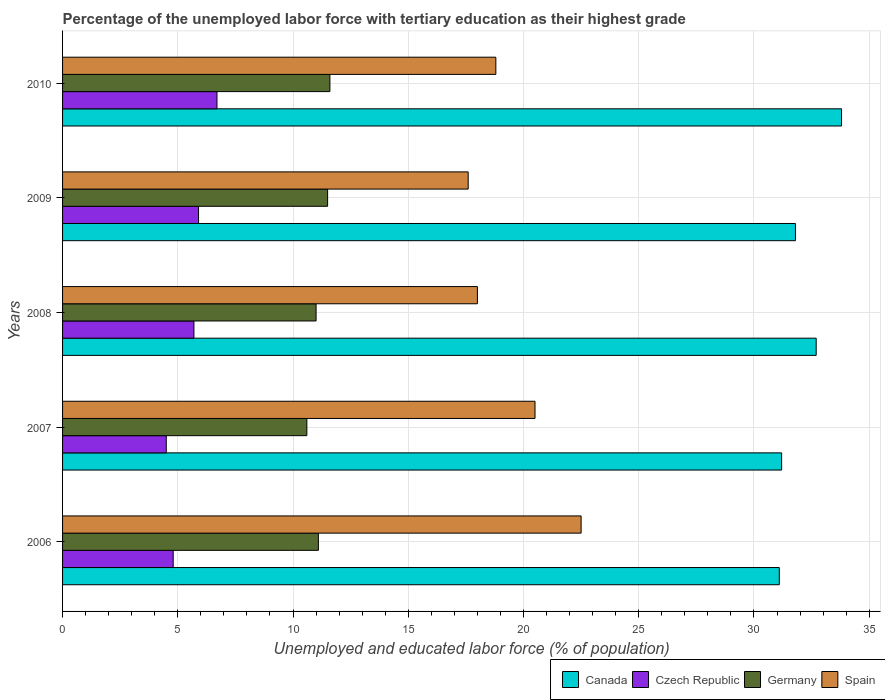How many different coloured bars are there?
Provide a short and direct response. 4. How many bars are there on the 3rd tick from the top?
Your answer should be very brief. 4. In how many cases, is the number of bars for a given year not equal to the number of legend labels?
Provide a short and direct response. 0. What is the percentage of the unemployed labor force with tertiary education in Czech Republic in 2008?
Your response must be concise. 5.7. Across all years, what is the minimum percentage of the unemployed labor force with tertiary education in Germany?
Ensure brevity in your answer.  10.6. In which year was the percentage of the unemployed labor force with tertiary education in Canada minimum?
Ensure brevity in your answer.  2006. What is the total percentage of the unemployed labor force with tertiary education in Canada in the graph?
Provide a short and direct response. 160.6. What is the difference between the percentage of the unemployed labor force with tertiary education in Spain in 2006 and that in 2009?
Give a very brief answer. 4.9. What is the difference between the percentage of the unemployed labor force with tertiary education in Czech Republic in 2008 and the percentage of the unemployed labor force with tertiary education in Canada in 2007?
Provide a succinct answer. -25.5. What is the average percentage of the unemployed labor force with tertiary education in Canada per year?
Ensure brevity in your answer.  32.12. In the year 2007, what is the difference between the percentage of the unemployed labor force with tertiary education in Germany and percentage of the unemployed labor force with tertiary education in Canada?
Provide a short and direct response. -20.6. What is the ratio of the percentage of the unemployed labor force with tertiary education in Spain in 2006 to that in 2007?
Give a very brief answer. 1.1. What is the difference between the highest and the second highest percentage of the unemployed labor force with tertiary education in Canada?
Ensure brevity in your answer.  1.1. What is the difference between the highest and the lowest percentage of the unemployed labor force with tertiary education in Germany?
Your answer should be very brief. 1. Is the sum of the percentage of the unemployed labor force with tertiary education in Spain in 2006 and 2009 greater than the maximum percentage of the unemployed labor force with tertiary education in Czech Republic across all years?
Provide a short and direct response. Yes. Is it the case that in every year, the sum of the percentage of the unemployed labor force with tertiary education in Spain and percentage of the unemployed labor force with tertiary education in Czech Republic is greater than the sum of percentage of the unemployed labor force with tertiary education in Germany and percentage of the unemployed labor force with tertiary education in Canada?
Make the answer very short. No. What does the 1st bar from the bottom in 2010 represents?
Provide a short and direct response. Canada. Is it the case that in every year, the sum of the percentage of the unemployed labor force with tertiary education in Germany and percentage of the unemployed labor force with tertiary education in Czech Republic is greater than the percentage of the unemployed labor force with tertiary education in Canada?
Make the answer very short. No. How many bars are there?
Your response must be concise. 20. Where does the legend appear in the graph?
Offer a very short reply. Bottom right. What is the title of the graph?
Make the answer very short. Percentage of the unemployed labor force with tertiary education as their highest grade. What is the label or title of the X-axis?
Provide a short and direct response. Unemployed and educated labor force (% of population). What is the label or title of the Y-axis?
Ensure brevity in your answer.  Years. What is the Unemployed and educated labor force (% of population) of Canada in 2006?
Offer a very short reply. 31.1. What is the Unemployed and educated labor force (% of population) in Czech Republic in 2006?
Give a very brief answer. 4.8. What is the Unemployed and educated labor force (% of population) in Germany in 2006?
Your response must be concise. 11.1. What is the Unemployed and educated labor force (% of population) in Canada in 2007?
Your answer should be very brief. 31.2. What is the Unemployed and educated labor force (% of population) of Czech Republic in 2007?
Your answer should be compact. 4.5. What is the Unemployed and educated labor force (% of population) in Germany in 2007?
Your answer should be very brief. 10.6. What is the Unemployed and educated labor force (% of population) of Canada in 2008?
Make the answer very short. 32.7. What is the Unemployed and educated labor force (% of population) of Czech Republic in 2008?
Offer a very short reply. 5.7. What is the Unemployed and educated labor force (% of population) in Canada in 2009?
Make the answer very short. 31.8. What is the Unemployed and educated labor force (% of population) of Czech Republic in 2009?
Provide a succinct answer. 5.9. What is the Unemployed and educated labor force (% of population) in Spain in 2009?
Your response must be concise. 17.6. What is the Unemployed and educated labor force (% of population) of Canada in 2010?
Your answer should be very brief. 33.8. What is the Unemployed and educated labor force (% of population) in Czech Republic in 2010?
Offer a very short reply. 6.7. What is the Unemployed and educated labor force (% of population) in Germany in 2010?
Provide a short and direct response. 11.6. What is the Unemployed and educated labor force (% of population) in Spain in 2010?
Give a very brief answer. 18.8. Across all years, what is the maximum Unemployed and educated labor force (% of population) of Canada?
Your response must be concise. 33.8. Across all years, what is the maximum Unemployed and educated labor force (% of population) of Czech Republic?
Keep it short and to the point. 6.7. Across all years, what is the maximum Unemployed and educated labor force (% of population) in Germany?
Make the answer very short. 11.6. Across all years, what is the maximum Unemployed and educated labor force (% of population) of Spain?
Your answer should be compact. 22.5. Across all years, what is the minimum Unemployed and educated labor force (% of population) of Canada?
Your answer should be compact. 31.1. Across all years, what is the minimum Unemployed and educated labor force (% of population) of Germany?
Your response must be concise. 10.6. Across all years, what is the minimum Unemployed and educated labor force (% of population) of Spain?
Provide a succinct answer. 17.6. What is the total Unemployed and educated labor force (% of population) in Canada in the graph?
Offer a very short reply. 160.6. What is the total Unemployed and educated labor force (% of population) of Czech Republic in the graph?
Your response must be concise. 27.6. What is the total Unemployed and educated labor force (% of population) in Germany in the graph?
Give a very brief answer. 55.8. What is the total Unemployed and educated labor force (% of population) in Spain in the graph?
Provide a succinct answer. 97.4. What is the difference between the Unemployed and educated labor force (% of population) in Czech Republic in 2006 and that in 2007?
Ensure brevity in your answer.  0.3. What is the difference between the Unemployed and educated labor force (% of population) of Spain in 2006 and that in 2007?
Keep it short and to the point. 2. What is the difference between the Unemployed and educated labor force (% of population) in Czech Republic in 2006 and that in 2008?
Make the answer very short. -0.9. What is the difference between the Unemployed and educated labor force (% of population) in Spain in 2006 and that in 2008?
Give a very brief answer. 4.5. What is the difference between the Unemployed and educated labor force (% of population) in Canada in 2006 and that in 2009?
Provide a succinct answer. -0.7. What is the difference between the Unemployed and educated labor force (% of population) of Czech Republic in 2006 and that in 2009?
Make the answer very short. -1.1. What is the difference between the Unemployed and educated labor force (% of population) in Spain in 2006 and that in 2009?
Offer a terse response. 4.9. What is the difference between the Unemployed and educated labor force (% of population) in Czech Republic in 2006 and that in 2010?
Give a very brief answer. -1.9. What is the difference between the Unemployed and educated labor force (% of population) in Germany in 2007 and that in 2008?
Ensure brevity in your answer.  -0.4. What is the difference between the Unemployed and educated labor force (% of population) of Spain in 2007 and that in 2008?
Offer a terse response. 2.5. What is the difference between the Unemployed and educated labor force (% of population) in Canada in 2007 and that in 2009?
Ensure brevity in your answer.  -0.6. What is the difference between the Unemployed and educated labor force (% of population) of Germany in 2007 and that in 2009?
Your answer should be compact. -0.9. What is the difference between the Unemployed and educated labor force (% of population) of Germany in 2007 and that in 2010?
Provide a succinct answer. -1. What is the difference between the Unemployed and educated labor force (% of population) of Spain in 2007 and that in 2010?
Offer a very short reply. 1.7. What is the difference between the Unemployed and educated labor force (% of population) in Canada in 2008 and that in 2009?
Your answer should be compact. 0.9. What is the difference between the Unemployed and educated labor force (% of population) of Czech Republic in 2008 and that in 2009?
Keep it short and to the point. -0.2. What is the difference between the Unemployed and educated labor force (% of population) in Germany in 2008 and that in 2009?
Offer a terse response. -0.5. What is the difference between the Unemployed and educated labor force (% of population) of Spain in 2008 and that in 2009?
Your response must be concise. 0.4. What is the difference between the Unemployed and educated labor force (% of population) in Germany in 2008 and that in 2010?
Provide a short and direct response. -0.6. What is the difference between the Unemployed and educated labor force (% of population) in Spain in 2008 and that in 2010?
Offer a very short reply. -0.8. What is the difference between the Unemployed and educated labor force (% of population) in Czech Republic in 2009 and that in 2010?
Your answer should be very brief. -0.8. What is the difference between the Unemployed and educated labor force (% of population) of Spain in 2009 and that in 2010?
Your answer should be compact. -1.2. What is the difference between the Unemployed and educated labor force (% of population) in Canada in 2006 and the Unemployed and educated labor force (% of population) in Czech Republic in 2007?
Give a very brief answer. 26.6. What is the difference between the Unemployed and educated labor force (% of population) in Canada in 2006 and the Unemployed and educated labor force (% of population) in Spain in 2007?
Ensure brevity in your answer.  10.6. What is the difference between the Unemployed and educated labor force (% of population) of Czech Republic in 2006 and the Unemployed and educated labor force (% of population) of Spain in 2007?
Ensure brevity in your answer.  -15.7. What is the difference between the Unemployed and educated labor force (% of population) in Canada in 2006 and the Unemployed and educated labor force (% of population) in Czech Republic in 2008?
Offer a terse response. 25.4. What is the difference between the Unemployed and educated labor force (% of population) in Canada in 2006 and the Unemployed and educated labor force (% of population) in Germany in 2008?
Provide a succinct answer. 20.1. What is the difference between the Unemployed and educated labor force (% of population) of Canada in 2006 and the Unemployed and educated labor force (% of population) of Czech Republic in 2009?
Offer a very short reply. 25.2. What is the difference between the Unemployed and educated labor force (% of population) in Canada in 2006 and the Unemployed and educated labor force (% of population) in Germany in 2009?
Your response must be concise. 19.6. What is the difference between the Unemployed and educated labor force (% of population) in Canada in 2006 and the Unemployed and educated labor force (% of population) in Spain in 2009?
Ensure brevity in your answer.  13.5. What is the difference between the Unemployed and educated labor force (% of population) in Czech Republic in 2006 and the Unemployed and educated labor force (% of population) in Spain in 2009?
Your answer should be very brief. -12.8. What is the difference between the Unemployed and educated labor force (% of population) in Germany in 2006 and the Unemployed and educated labor force (% of population) in Spain in 2009?
Keep it short and to the point. -6.5. What is the difference between the Unemployed and educated labor force (% of population) in Canada in 2006 and the Unemployed and educated labor force (% of population) in Czech Republic in 2010?
Your answer should be very brief. 24.4. What is the difference between the Unemployed and educated labor force (% of population) in Canada in 2006 and the Unemployed and educated labor force (% of population) in Germany in 2010?
Ensure brevity in your answer.  19.5. What is the difference between the Unemployed and educated labor force (% of population) of Canada in 2006 and the Unemployed and educated labor force (% of population) of Spain in 2010?
Provide a succinct answer. 12.3. What is the difference between the Unemployed and educated labor force (% of population) in Czech Republic in 2006 and the Unemployed and educated labor force (% of population) in Germany in 2010?
Keep it short and to the point. -6.8. What is the difference between the Unemployed and educated labor force (% of population) in Canada in 2007 and the Unemployed and educated labor force (% of population) in Czech Republic in 2008?
Make the answer very short. 25.5. What is the difference between the Unemployed and educated labor force (% of population) of Canada in 2007 and the Unemployed and educated labor force (% of population) of Germany in 2008?
Ensure brevity in your answer.  20.2. What is the difference between the Unemployed and educated labor force (% of population) of Canada in 2007 and the Unemployed and educated labor force (% of population) of Spain in 2008?
Your answer should be compact. 13.2. What is the difference between the Unemployed and educated labor force (% of population) of Czech Republic in 2007 and the Unemployed and educated labor force (% of population) of Germany in 2008?
Your response must be concise. -6.5. What is the difference between the Unemployed and educated labor force (% of population) in Czech Republic in 2007 and the Unemployed and educated labor force (% of population) in Spain in 2008?
Provide a succinct answer. -13.5. What is the difference between the Unemployed and educated labor force (% of population) in Canada in 2007 and the Unemployed and educated labor force (% of population) in Czech Republic in 2009?
Your answer should be compact. 25.3. What is the difference between the Unemployed and educated labor force (% of population) in Canada in 2007 and the Unemployed and educated labor force (% of population) in Germany in 2009?
Provide a short and direct response. 19.7. What is the difference between the Unemployed and educated labor force (% of population) of Czech Republic in 2007 and the Unemployed and educated labor force (% of population) of Spain in 2009?
Give a very brief answer. -13.1. What is the difference between the Unemployed and educated labor force (% of population) in Germany in 2007 and the Unemployed and educated labor force (% of population) in Spain in 2009?
Your answer should be compact. -7. What is the difference between the Unemployed and educated labor force (% of population) in Canada in 2007 and the Unemployed and educated labor force (% of population) in Czech Republic in 2010?
Provide a short and direct response. 24.5. What is the difference between the Unemployed and educated labor force (% of population) of Canada in 2007 and the Unemployed and educated labor force (% of population) of Germany in 2010?
Provide a succinct answer. 19.6. What is the difference between the Unemployed and educated labor force (% of population) of Czech Republic in 2007 and the Unemployed and educated labor force (% of population) of Germany in 2010?
Your answer should be compact. -7.1. What is the difference between the Unemployed and educated labor force (% of population) of Czech Republic in 2007 and the Unemployed and educated labor force (% of population) of Spain in 2010?
Keep it short and to the point. -14.3. What is the difference between the Unemployed and educated labor force (% of population) in Canada in 2008 and the Unemployed and educated labor force (% of population) in Czech Republic in 2009?
Your answer should be very brief. 26.8. What is the difference between the Unemployed and educated labor force (% of population) in Canada in 2008 and the Unemployed and educated labor force (% of population) in Germany in 2009?
Make the answer very short. 21.2. What is the difference between the Unemployed and educated labor force (% of population) in Czech Republic in 2008 and the Unemployed and educated labor force (% of population) in Germany in 2009?
Keep it short and to the point. -5.8. What is the difference between the Unemployed and educated labor force (% of population) in Germany in 2008 and the Unemployed and educated labor force (% of population) in Spain in 2009?
Make the answer very short. -6.6. What is the difference between the Unemployed and educated labor force (% of population) in Canada in 2008 and the Unemployed and educated labor force (% of population) in Czech Republic in 2010?
Your answer should be compact. 26. What is the difference between the Unemployed and educated labor force (% of population) in Canada in 2008 and the Unemployed and educated labor force (% of population) in Germany in 2010?
Ensure brevity in your answer.  21.1. What is the difference between the Unemployed and educated labor force (% of population) of Czech Republic in 2008 and the Unemployed and educated labor force (% of population) of Germany in 2010?
Ensure brevity in your answer.  -5.9. What is the difference between the Unemployed and educated labor force (% of population) of Czech Republic in 2008 and the Unemployed and educated labor force (% of population) of Spain in 2010?
Provide a short and direct response. -13.1. What is the difference between the Unemployed and educated labor force (% of population) of Canada in 2009 and the Unemployed and educated labor force (% of population) of Czech Republic in 2010?
Your response must be concise. 25.1. What is the difference between the Unemployed and educated labor force (% of population) in Canada in 2009 and the Unemployed and educated labor force (% of population) in Germany in 2010?
Give a very brief answer. 20.2. What is the difference between the Unemployed and educated labor force (% of population) in Czech Republic in 2009 and the Unemployed and educated labor force (% of population) in Germany in 2010?
Your response must be concise. -5.7. What is the difference between the Unemployed and educated labor force (% of population) in Germany in 2009 and the Unemployed and educated labor force (% of population) in Spain in 2010?
Your answer should be compact. -7.3. What is the average Unemployed and educated labor force (% of population) in Canada per year?
Ensure brevity in your answer.  32.12. What is the average Unemployed and educated labor force (% of population) of Czech Republic per year?
Your response must be concise. 5.52. What is the average Unemployed and educated labor force (% of population) of Germany per year?
Your answer should be compact. 11.16. What is the average Unemployed and educated labor force (% of population) of Spain per year?
Ensure brevity in your answer.  19.48. In the year 2006, what is the difference between the Unemployed and educated labor force (% of population) of Canada and Unemployed and educated labor force (% of population) of Czech Republic?
Offer a very short reply. 26.3. In the year 2006, what is the difference between the Unemployed and educated labor force (% of population) of Canada and Unemployed and educated labor force (% of population) of Spain?
Offer a terse response. 8.6. In the year 2006, what is the difference between the Unemployed and educated labor force (% of population) in Czech Republic and Unemployed and educated labor force (% of population) in Germany?
Offer a terse response. -6.3. In the year 2006, what is the difference between the Unemployed and educated labor force (% of population) of Czech Republic and Unemployed and educated labor force (% of population) of Spain?
Ensure brevity in your answer.  -17.7. In the year 2007, what is the difference between the Unemployed and educated labor force (% of population) in Canada and Unemployed and educated labor force (% of population) in Czech Republic?
Your answer should be very brief. 26.7. In the year 2007, what is the difference between the Unemployed and educated labor force (% of population) in Canada and Unemployed and educated labor force (% of population) in Germany?
Provide a succinct answer. 20.6. In the year 2007, what is the difference between the Unemployed and educated labor force (% of population) in Czech Republic and Unemployed and educated labor force (% of population) in Germany?
Provide a short and direct response. -6.1. In the year 2007, what is the difference between the Unemployed and educated labor force (% of population) in Czech Republic and Unemployed and educated labor force (% of population) in Spain?
Your answer should be compact. -16. In the year 2008, what is the difference between the Unemployed and educated labor force (% of population) in Canada and Unemployed and educated labor force (% of population) in Czech Republic?
Provide a short and direct response. 27. In the year 2008, what is the difference between the Unemployed and educated labor force (% of population) in Canada and Unemployed and educated labor force (% of population) in Germany?
Provide a short and direct response. 21.7. In the year 2008, what is the difference between the Unemployed and educated labor force (% of population) in Czech Republic and Unemployed and educated labor force (% of population) in Germany?
Your answer should be very brief. -5.3. In the year 2008, what is the difference between the Unemployed and educated labor force (% of population) of Czech Republic and Unemployed and educated labor force (% of population) of Spain?
Offer a very short reply. -12.3. In the year 2008, what is the difference between the Unemployed and educated labor force (% of population) of Germany and Unemployed and educated labor force (% of population) of Spain?
Provide a succinct answer. -7. In the year 2009, what is the difference between the Unemployed and educated labor force (% of population) in Canada and Unemployed and educated labor force (% of population) in Czech Republic?
Offer a very short reply. 25.9. In the year 2009, what is the difference between the Unemployed and educated labor force (% of population) of Canada and Unemployed and educated labor force (% of population) of Germany?
Offer a terse response. 20.3. In the year 2009, what is the difference between the Unemployed and educated labor force (% of population) in Canada and Unemployed and educated labor force (% of population) in Spain?
Provide a succinct answer. 14.2. In the year 2009, what is the difference between the Unemployed and educated labor force (% of population) in Czech Republic and Unemployed and educated labor force (% of population) in Germany?
Your response must be concise. -5.6. In the year 2009, what is the difference between the Unemployed and educated labor force (% of population) of Czech Republic and Unemployed and educated labor force (% of population) of Spain?
Offer a very short reply. -11.7. In the year 2009, what is the difference between the Unemployed and educated labor force (% of population) in Germany and Unemployed and educated labor force (% of population) in Spain?
Your answer should be very brief. -6.1. In the year 2010, what is the difference between the Unemployed and educated labor force (% of population) of Canada and Unemployed and educated labor force (% of population) of Czech Republic?
Offer a very short reply. 27.1. In the year 2010, what is the difference between the Unemployed and educated labor force (% of population) of Canada and Unemployed and educated labor force (% of population) of Spain?
Your response must be concise. 15. In the year 2010, what is the difference between the Unemployed and educated labor force (% of population) in Czech Republic and Unemployed and educated labor force (% of population) in Germany?
Ensure brevity in your answer.  -4.9. What is the ratio of the Unemployed and educated labor force (% of population) in Czech Republic in 2006 to that in 2007?
Ensure brevity in your answer.  1.07. What is the ratio of the Unemployed and educated labor force (% of population) in Germany in 2006 to that in 2007?
Offer a terse response. 1.05. What is the ratio of the Unemployed and educated labor force (% of population) of Spain in 2006 to that in 2007?
Make the answer very short. 1.1. What is the ratio of the Unemployed and educated labor force (% of population) of Canada in 2006 to that in 2008?
Ensure brevity in your answer.  0.95. What is the ratio of the Unemployed and educated labor force (% of population) of Czech Republic in 2006 to that in 2008?
Offer a very short reply. 0.84. What is the ratio of the Unemployed and educated labor force (% of population) in Germany in 2006 to that in 2008?
Make the answer very short. 1.01. What is the ratio of the Unemployed and educated labor force (% of population) in Spain in 2006 to that in 2008?
Provide a short and direct response. 1.25. What is the ratio of the Unemployed and educated labor force (% of population) in Czech Republic in 2006 to that in 2009?
Keep it short and to the point. 0.81. What is the ratio of the Unemployed and educated labor force (% of population) in Germany in 2006 to that in 2009?
Provide a succinct answer. 0.97. What is the ratio of the Unemployed and educated labor force (% of population) of Spain in 2006 to that in 2009?
Make the answer very short. 1.28. What is the ratio of the Unemployed and educated labor force (% of population) of Canada in 2006 to that in 2010?
Your response must be concise. 0.92. What is the ratio of the Unemployed and educated labor force (% of population) in Czech Republic in 2006 to that in 2010?
Provide a short and direct response. 0.72. What is the ratio of the Unemployed and educated labor force (% of population) in Germany in 2006 to that in 2010?
Your answer should be compact. 0.96. What is the ratio of the Unemployed and educated labor force (% of population) in Spain in 2006 to that in 2010?
Your answer should be compact. 1.2. What is the ratio of the Unemployed and educated labor force (% of population) in Canada in 2007 to that in 2008?
Your answer should be very brief. 0.95. What is the ratio of the Unemployed and educated labor force (% of population) in Czech Republic in 2007 to that in 2008?
Provide a short and direct response. 0.79. What is the ratio of the Unemployed and educated labor force (% of population) in Germany in 2007 to that in 2008?
Keep it short and to the point. 0.96. What is the ratio of the Unemployed and educated labor force (% of population) in Spain in 2007 to that in 2008?
Provide a short and direct response. 1.14. What is the ratio of the Unemployed and educated labor force (% of population) in Canada in 2007 to that in 2009?
Give a very brief answer. 0.98. What is the ratio of the Unemployed and educated labor force (% of population) of Czech Republic in 2007 to that in 2009?
Your response must be concise. 0.76. What is the ratio of the Unemployed and educated labor force (% of population) of Germany in 2007 to that in 2009?
Your answer should be compact. 0.92. What is the ratio of the Unemployed and educated labor force (% of population) of Spain in 2007 to that in 2009?
Your answer should be compact. 1.16. What is the ratio of the Unemployed and educated labor force (% of population) in Canada in 2007 to that in 2010?
Provide a short and direct response. 0.92. What is the ratio of the Unemployed and educated labor force (% of population) in Czech Republic in 2007 to that in 2010?
Keep it short and to the point. 0.67. What is the ratio of the Unemployed and educated labor force (% of population) in Germany in 2007 to that in 2010?
Offer a terse response. 0.91. What is the ratio of the Unemployed and educated labor force (% of population) in Spain in 2007 to that in 2010?
Make the answer very short. 1.09. What is the ratio of the Unemployed and educated labor force (% of population) in Canada in 2008 to that in 2009?
Provide a succinct answer. 1.03. What is the ratio of the Unemployed and educated labor force (% of population) in Czech Republic in 2008 to that in 2009?
Your answer should be very brief. 0.97. What is the ratio of the Unemployed and educated labor force (% of population) in Germany in 2008 to that in 2009?
Give a very brief answer. 0.96. What is the ratio of the Unemployed and educated labor force (% of population) in Spain in 2008 to that in 2009?
Your answer should be very brief. 1.02. What is the ratio of the Unemployed and educated labor force (% of population) of Canada in 2008 to that in 2010?
Offer a terse response. 0.97. What is the ratio of the Unemployed and educated labor force (% of population) in Czech Republic in 2008 to that in 2010?
Provide a short and direct response. 0.85. What is the ratio of the Unemployed and educated labor force (% of population) of Germany in 2008 to that in 2010?
Your answer should be compact. 0.95. What is the ratio of the Unemployed and educated labor force (% of population) in Spain in 2008 to that in 2010?
Offer a terse response. 0.96. What is the ratio of the Unemployed and educated labor force (% of population) of Canada in 2009 to that in 2010?
Your response must be concise. 0.94. What is the ratio of the Unemployed and educated labor force (% of population) in Czech Republic in 2009 to that in 2010?
Provide a succinct answer. 0.88. What is the ratio of the Unemployed and educated labor force (% of population) of Spain in 2009 to that in 2010?
Offer a very short reply. 0.94. What is the difference between the highest and the second highest Unemployed and educated labor force (% of population) of Czech Republic?
Offer a very short reply. 0.8. What is the difference between the highest and the second highest Unemployed and educated labor force (% of population) in Germany?
Offer a terse response. 0.1. What is the difference between the highest and the lowest Unemployed and educated labor force (% of population) in Spain?
Offer a very short reply. 4.9. 